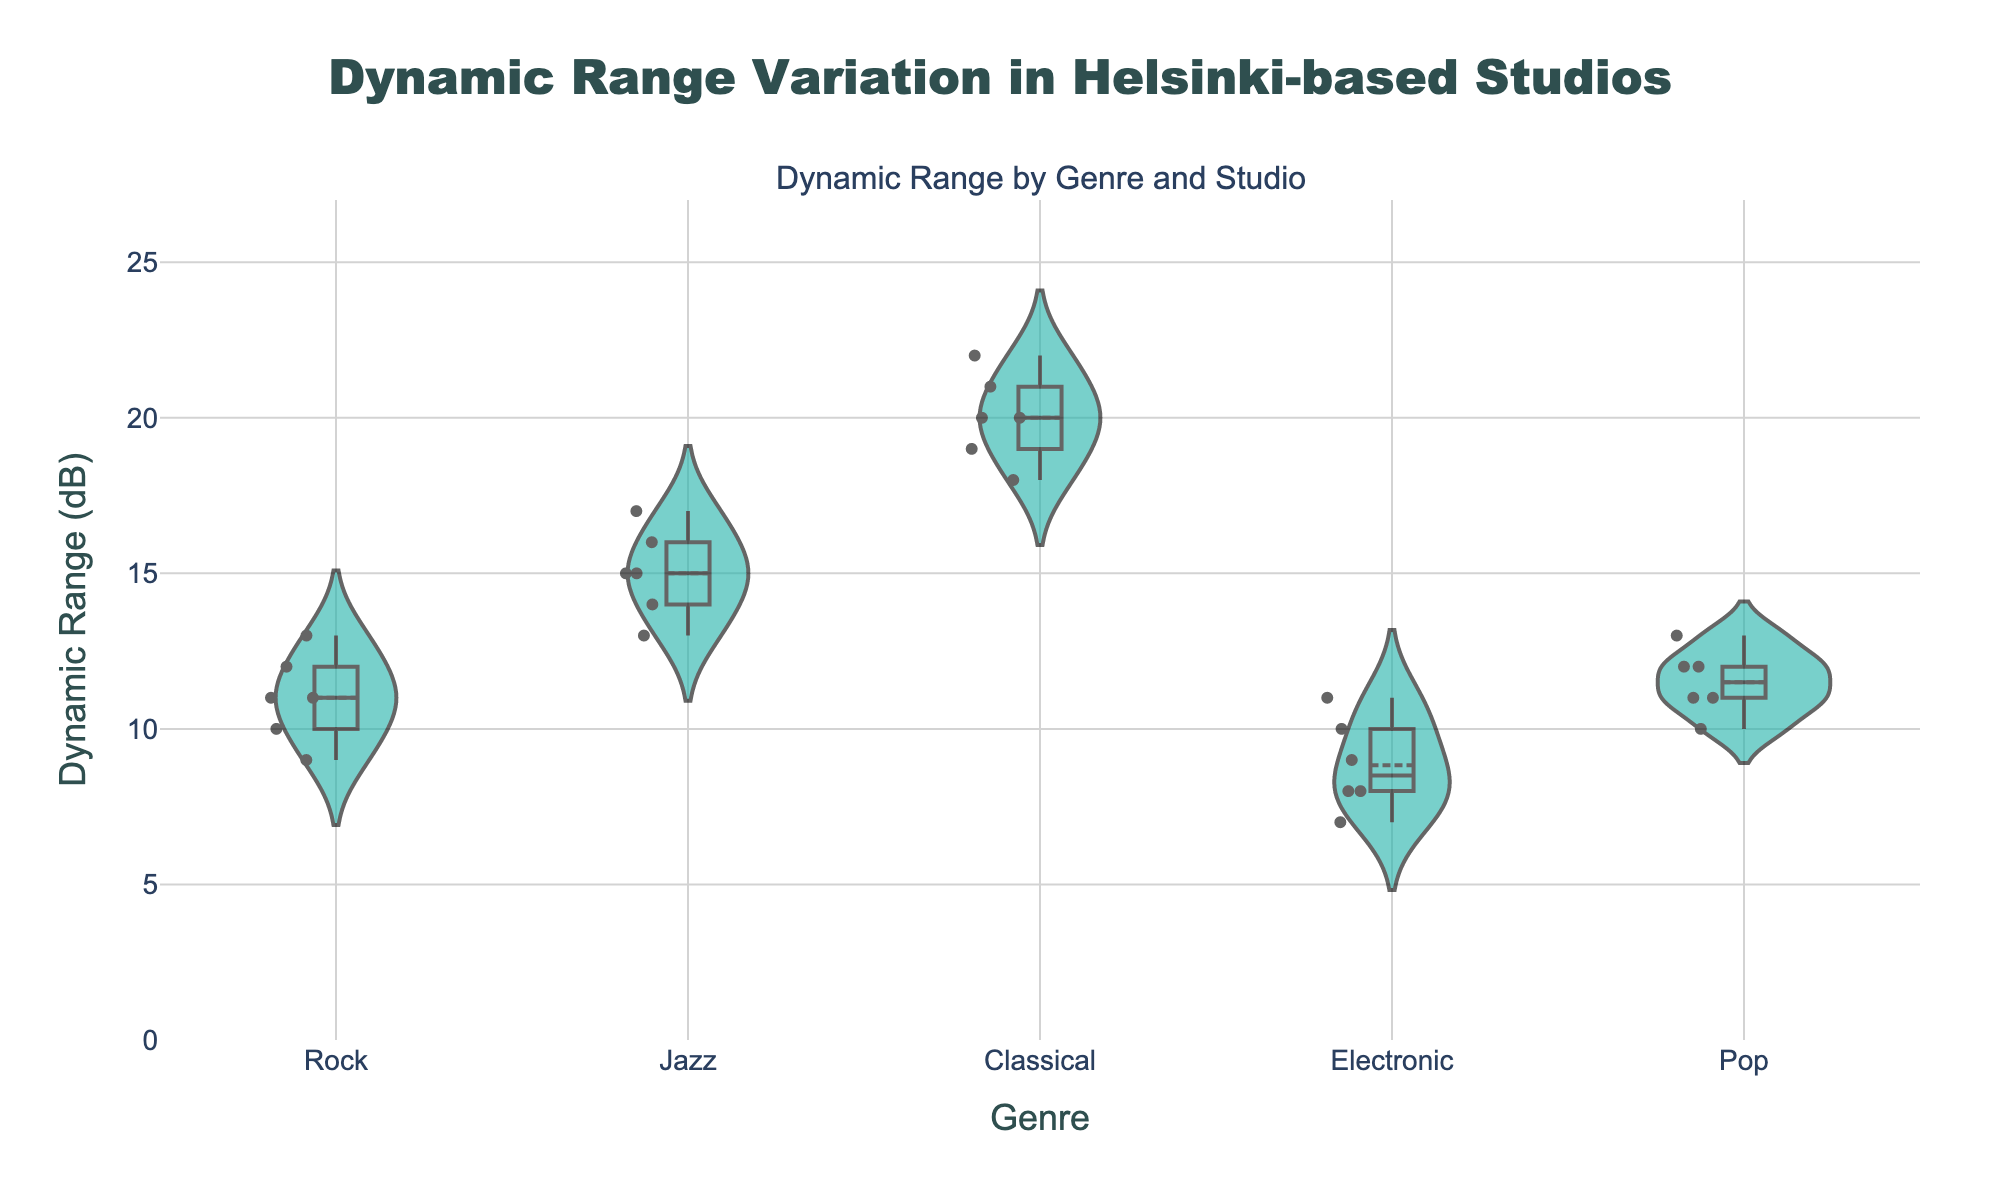What's the title of the plot? The title of the plot is typically located at the top of the figure. From the provided code, the title is configured under the 'title' key in the 'update_layout' section. The title text is "Dynamic Range Variation in Helsinki-based Studios".
Answer: Dynamic Range Variation in Helsinki-based Studios What are the axes labels? The axes labels can be identified from the 'xaxis_title' and 'yaxis_title' in the plot's layout settings. They are "Genre" for the x-axis and "Dynamic Range (dB)" for the y-axis.
Answer: Genre and Dynamic Range (dB) How many data points are there for the Rock genre? By counting the number of points associated with the Rock genre on the plot, we see six data points (9, 11, 12 for Sonic Boom Studios; 10, 11, 13 for Waveform Helsinki).
Answer: 6 Which genre has the highest median dynamic range? To determine the genre with the highest median dynamic range, we compare the median values for all genres displayed on the plot. "Classical" has the highest median with values around 20-22 dB.
Answer: Classical What is the dynamic range value for Jazz at Groove Lab with the highest value? From the plot, identify the highest point associated with Jazz at Groove Lab. The highest value is 17 dB.
Answer: 17 dB Compare the dynamic range variation between Electronic and Pop genres. Which has greater variation? Looking at the spread of the dynamic range values in the violins for Electronic and Pop genres, Electronic spans from 7 to 11 dB, while Pop spans from 10 to 13 dB. The greater variation is for Electronic with a range of 4 dB.
Answer: Electronic Which studio contributes the highest dynamic range value for Classical music? Identify the studios producing Classical music and compare their highest values. Symphony Records has the highest value, which is 22 dB.
Answer: Symphony Records What is the mean dynamic range of the Jazz genre? For Jazz, sum the dynamic range values (14, 15, 13 for Blue Note Productions; 17, 16, 15 for Groove Lab) and divide by the total number of values (6). The mean is (14+15+13+17+16+15)/6 = 15.
Answer: 15 How does the dynamic range for Rock compare between Sonic Boom Studios and Waveform Helsinki? By visually comparing the dynamic ranges for Rock at the two studios, it appears both studios have overlapping ranges (9-12 for Sonic Boom Studios and 10-13 for Waveform Helsinki). Their ranges are very similar with a slight overlap.
Answer: Similar Which genre has the lowest minimum dynamic range value overall? Identify the lowest points in all the genres on the plot. Electronic has the lowest minimum value overall with a range starting at 7 dB.
Answer: Electronic 